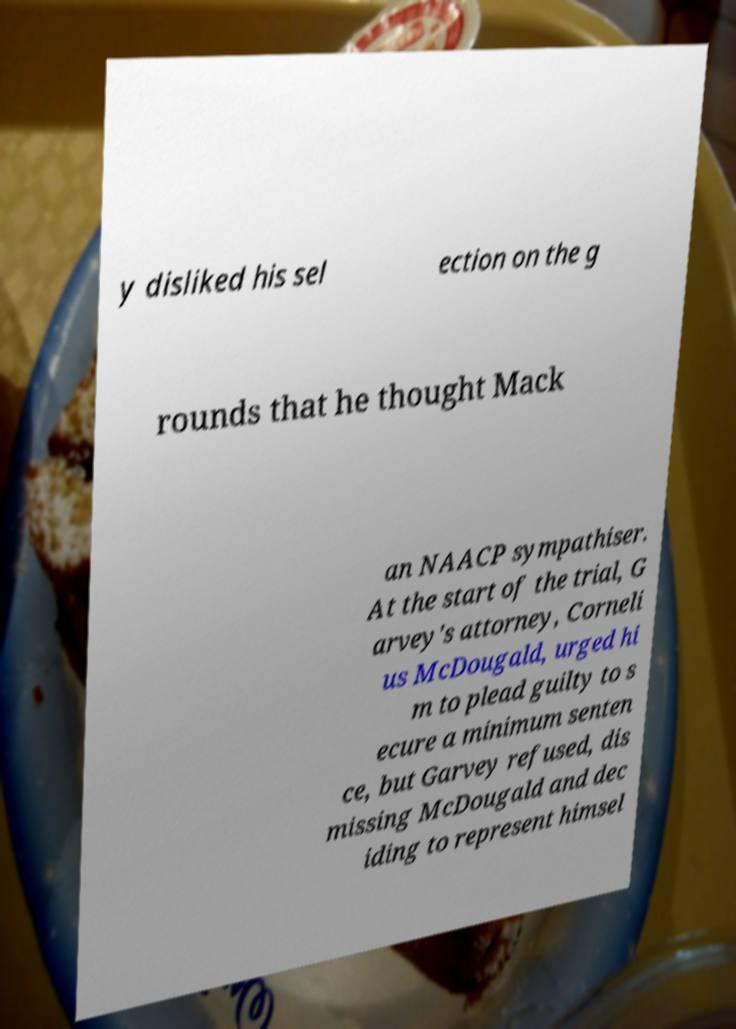For documentation purposes, I need the text within this image transcribed. Could you provide that? y disliked his sel ection on the g rounds that he thought Mack an NAACP sympathiser. At the start of the trial, G arvey's attorney, Corneli us McDougald, urged hi m to plead guilty to s ecure a minimum senten ce, but Garvey refused, dis missing McDougald and dec iding to represent himsel 